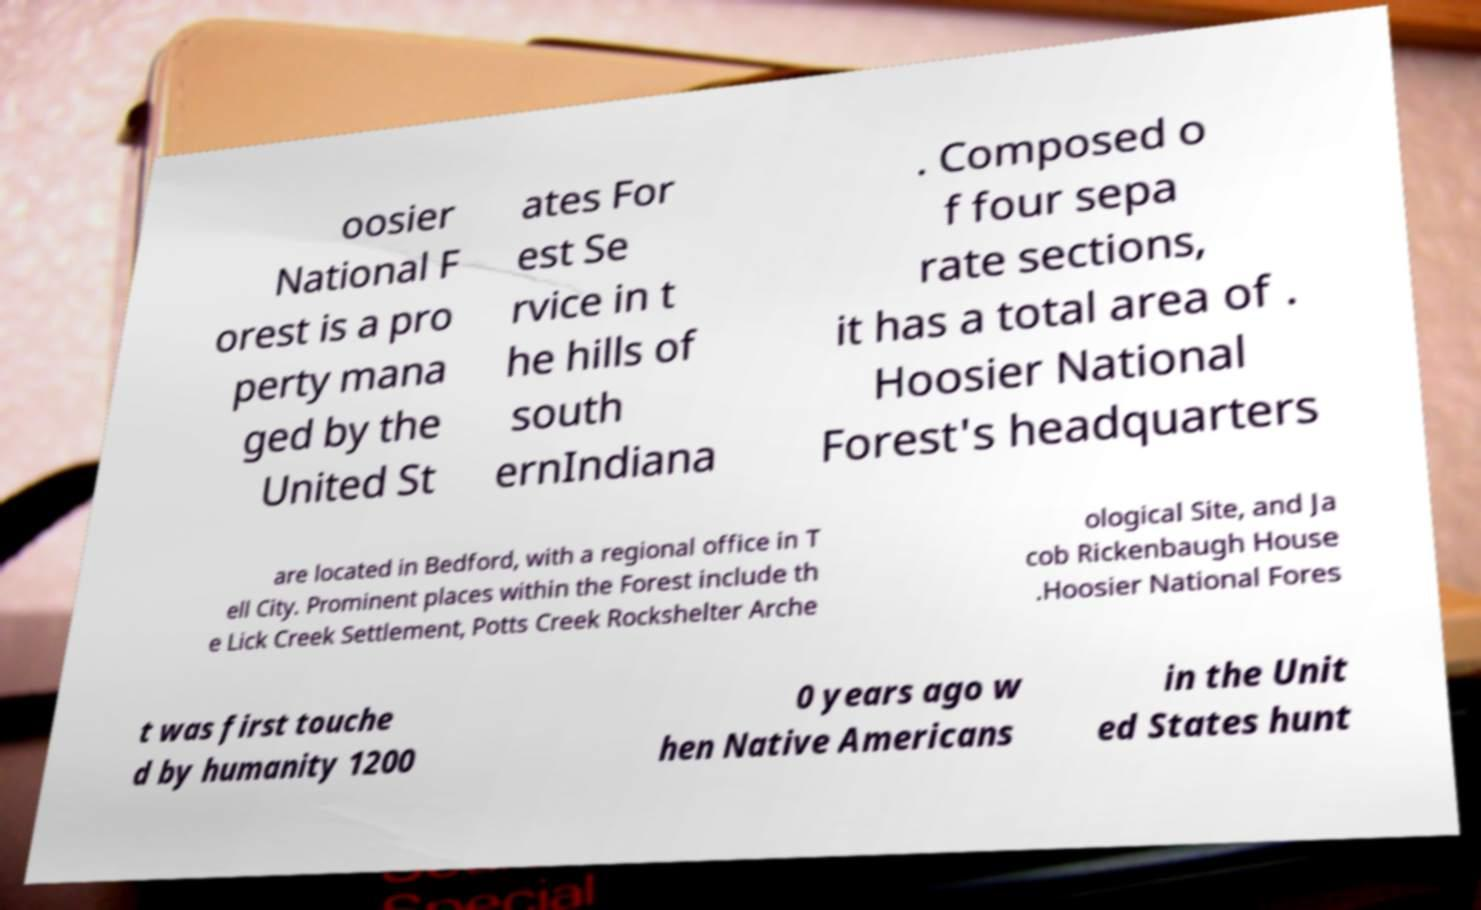Please identify and transcribe the text found in this image. oosier National F orest is a pro perty mana ged by the United St ates For est Se rvice in t he hills of south ernIndiana . Composed o f four sepa rate sections, it has a total area of . Hoosier National Forest's headquarters are located in Bedford, with a regional office in T ell City. Prominent places within the Forest include th e Lick Creek Settlement, Potts Creek Rockshelter Arche ological Site, and Ja cob Rickenbaugh House .Hoosier National Fores t was first touche d by humanity 1200 0 years ago w hen Native Americans in the Unit ed States hunt 